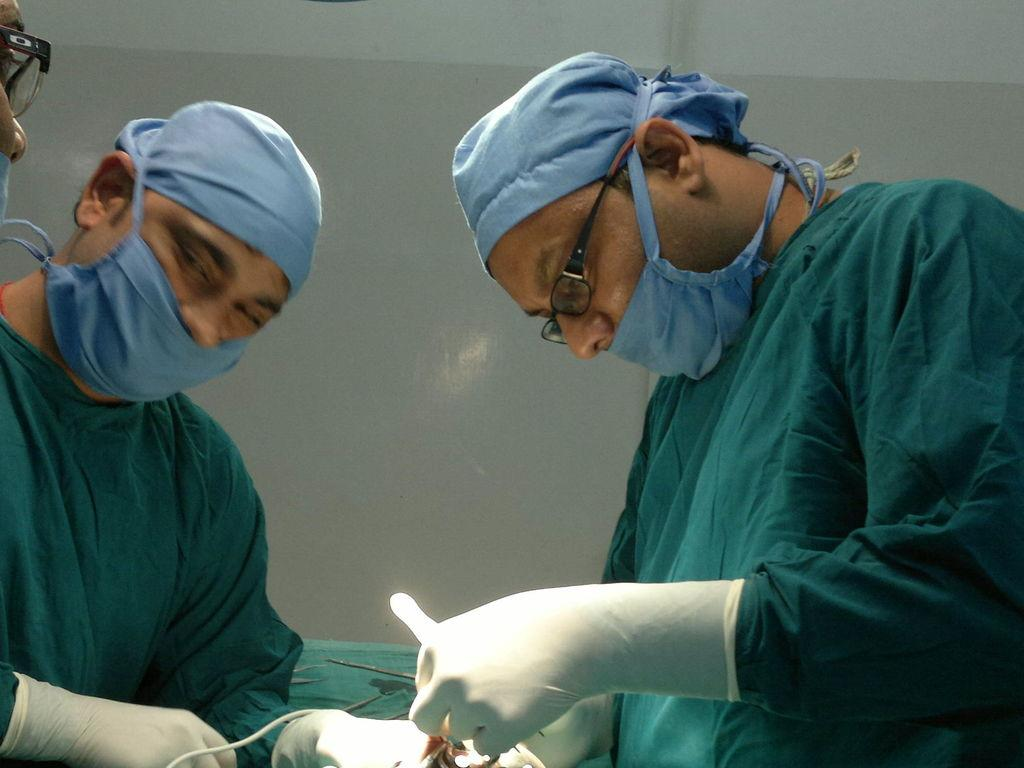How many people are in the image? There are three persons in the image. What are the persons doing in the image? The persons are standing in the image. What are the persons holding in their hands? The persons are holding something in their hands. What can be seen in the background of the image? There is a wall in the background of the image. What type of vase can be seen in the middle of the image? There is no vase present in the image. What color is the sheet draped over the middle person in the image? There is no sheet draped over any person in the image. 